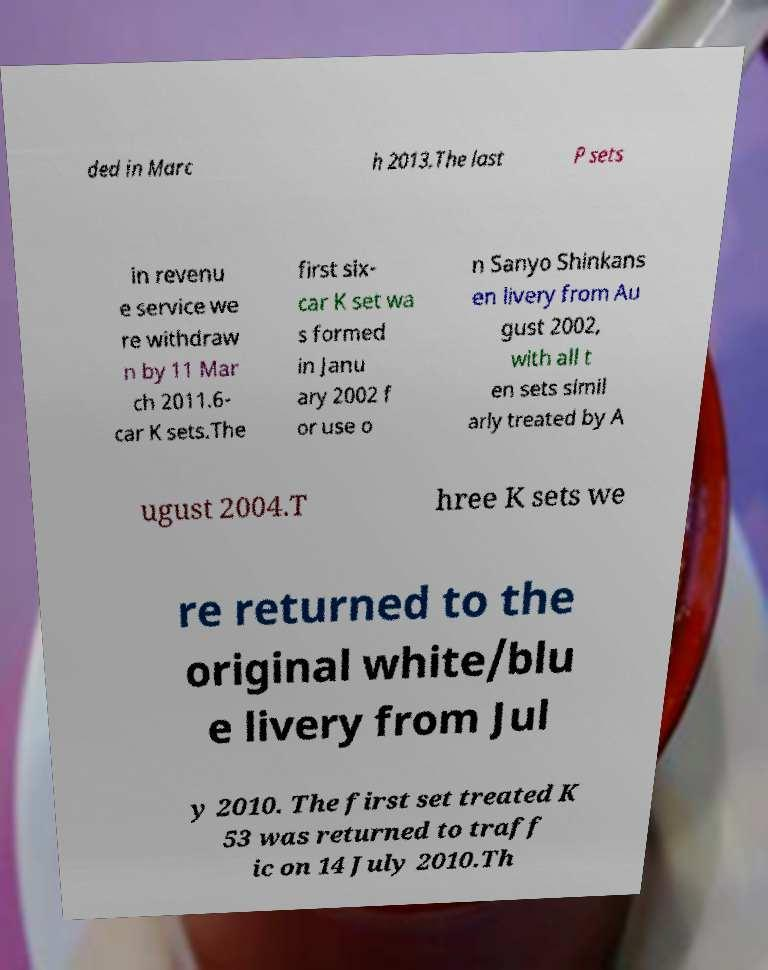For documentation purposes, I need the text within this image transcribed. Could you provide that? ded in Marc h 2013.The last P sets in revenu e service we re withdraw n by 11 Mar ch 2011.6- car K sets.The first six- car K set wa s formed in Janu ary 2002 f or use o n Sanyo Shinkans en livery from Au gust 2002, with all t en sets simil arly treated by A ugust 2004.T hree K sets we re returned to the original white/blu e livery from Jul y 2010. The first set treated K 53 was returned to traff ic on 14 July 2010.Th 